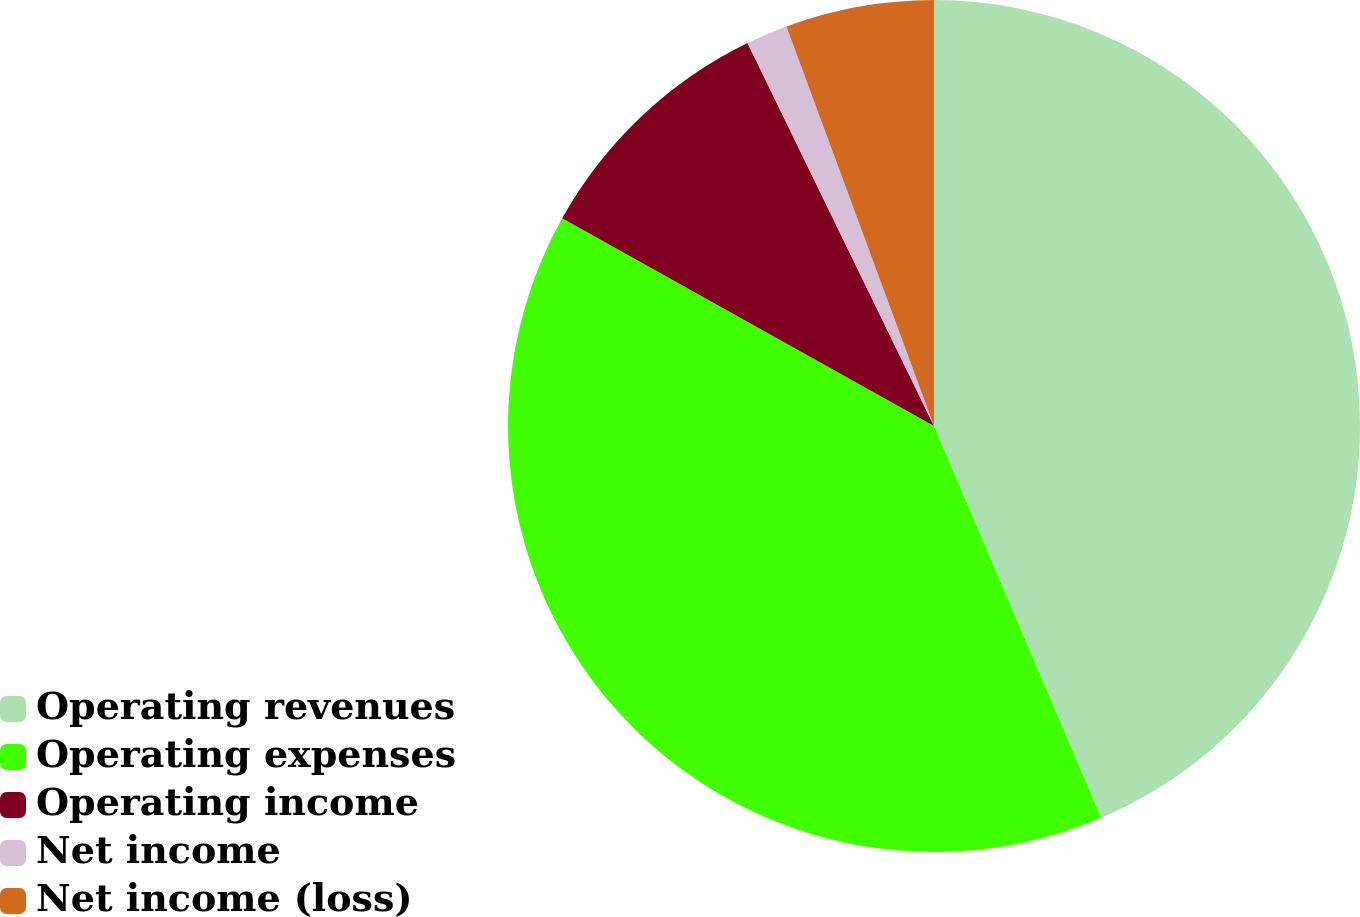Convert chart to OTSL. <chart><loc_0><loc_0><loc_500><loc_500><pie_chart><fcel>Operating revenues<fcel>Operating expenses<fcel>Operating income<fcel>Net income<fcel>Net income (loss)<nl><fcel>43.58%<fcel>39.53%<fcel>9.68%<fcel>1.58%<fcel>5.63%<nl></chart> 